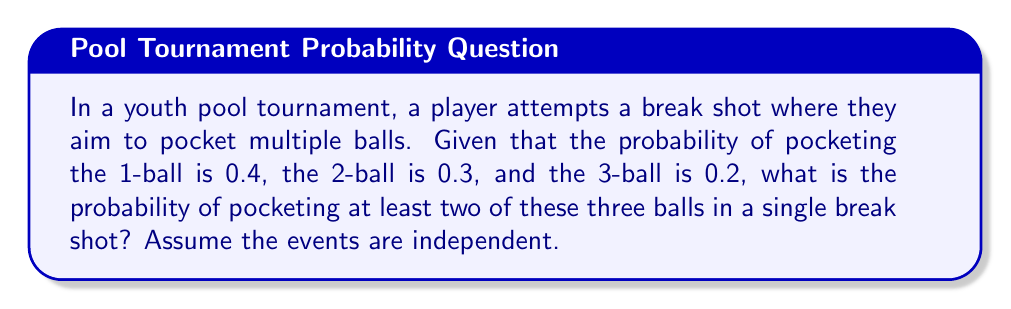Teach me how to tackle this problem. Let's approach this step-by-step:

1) First, let's define our events:
   A: pocketing the 1-ball (P(A) = 0.4)
   B: pocketing the 2-ball (P(B) = 0.3)
   C: pocketing the 3-ball (P(C) = 0.2)

2) We want to find the probability of pocketing at least two balls. It's easier to calculate the complement of this event: the probability of pocketing one or zero balls.

3) Probability of pocketing zero balls:
   $P(\text{none}) = (1-0.4)(1-0.3)(1-0.2) = 0.6 \times 0.7 \times 0.8 = 0.336$

4) Probability of pocketing exactly one ball:
   $P(\text{only A}) = 0.4 \times 0.7 \times 0.8 = 0.224$
   $P(\text{only B}) = 0.6 \times 0.3 \times 0.8 = 0.144$
   $P(\text{only C}) = 0.6 \times 0.7 \times 0.2 = 0.084$
   
   $P(\text{exactly one}) = 0.224 + 0.144 + 0.084 = 0.452$

5) Probability of pocketing one or zero balls:
   $P(\text{one or zero}) = P(\text{none}) + P(\text{exactly one}) = 0.336 + 0.452 = 0.788$

6) Therefore, the probability of pocketing at least two balls is:
   $P(\text{at least two}) = 1 - P(\text{one or zero}) = 1 - 0.788 = 0.212$
Answer: 0.212 